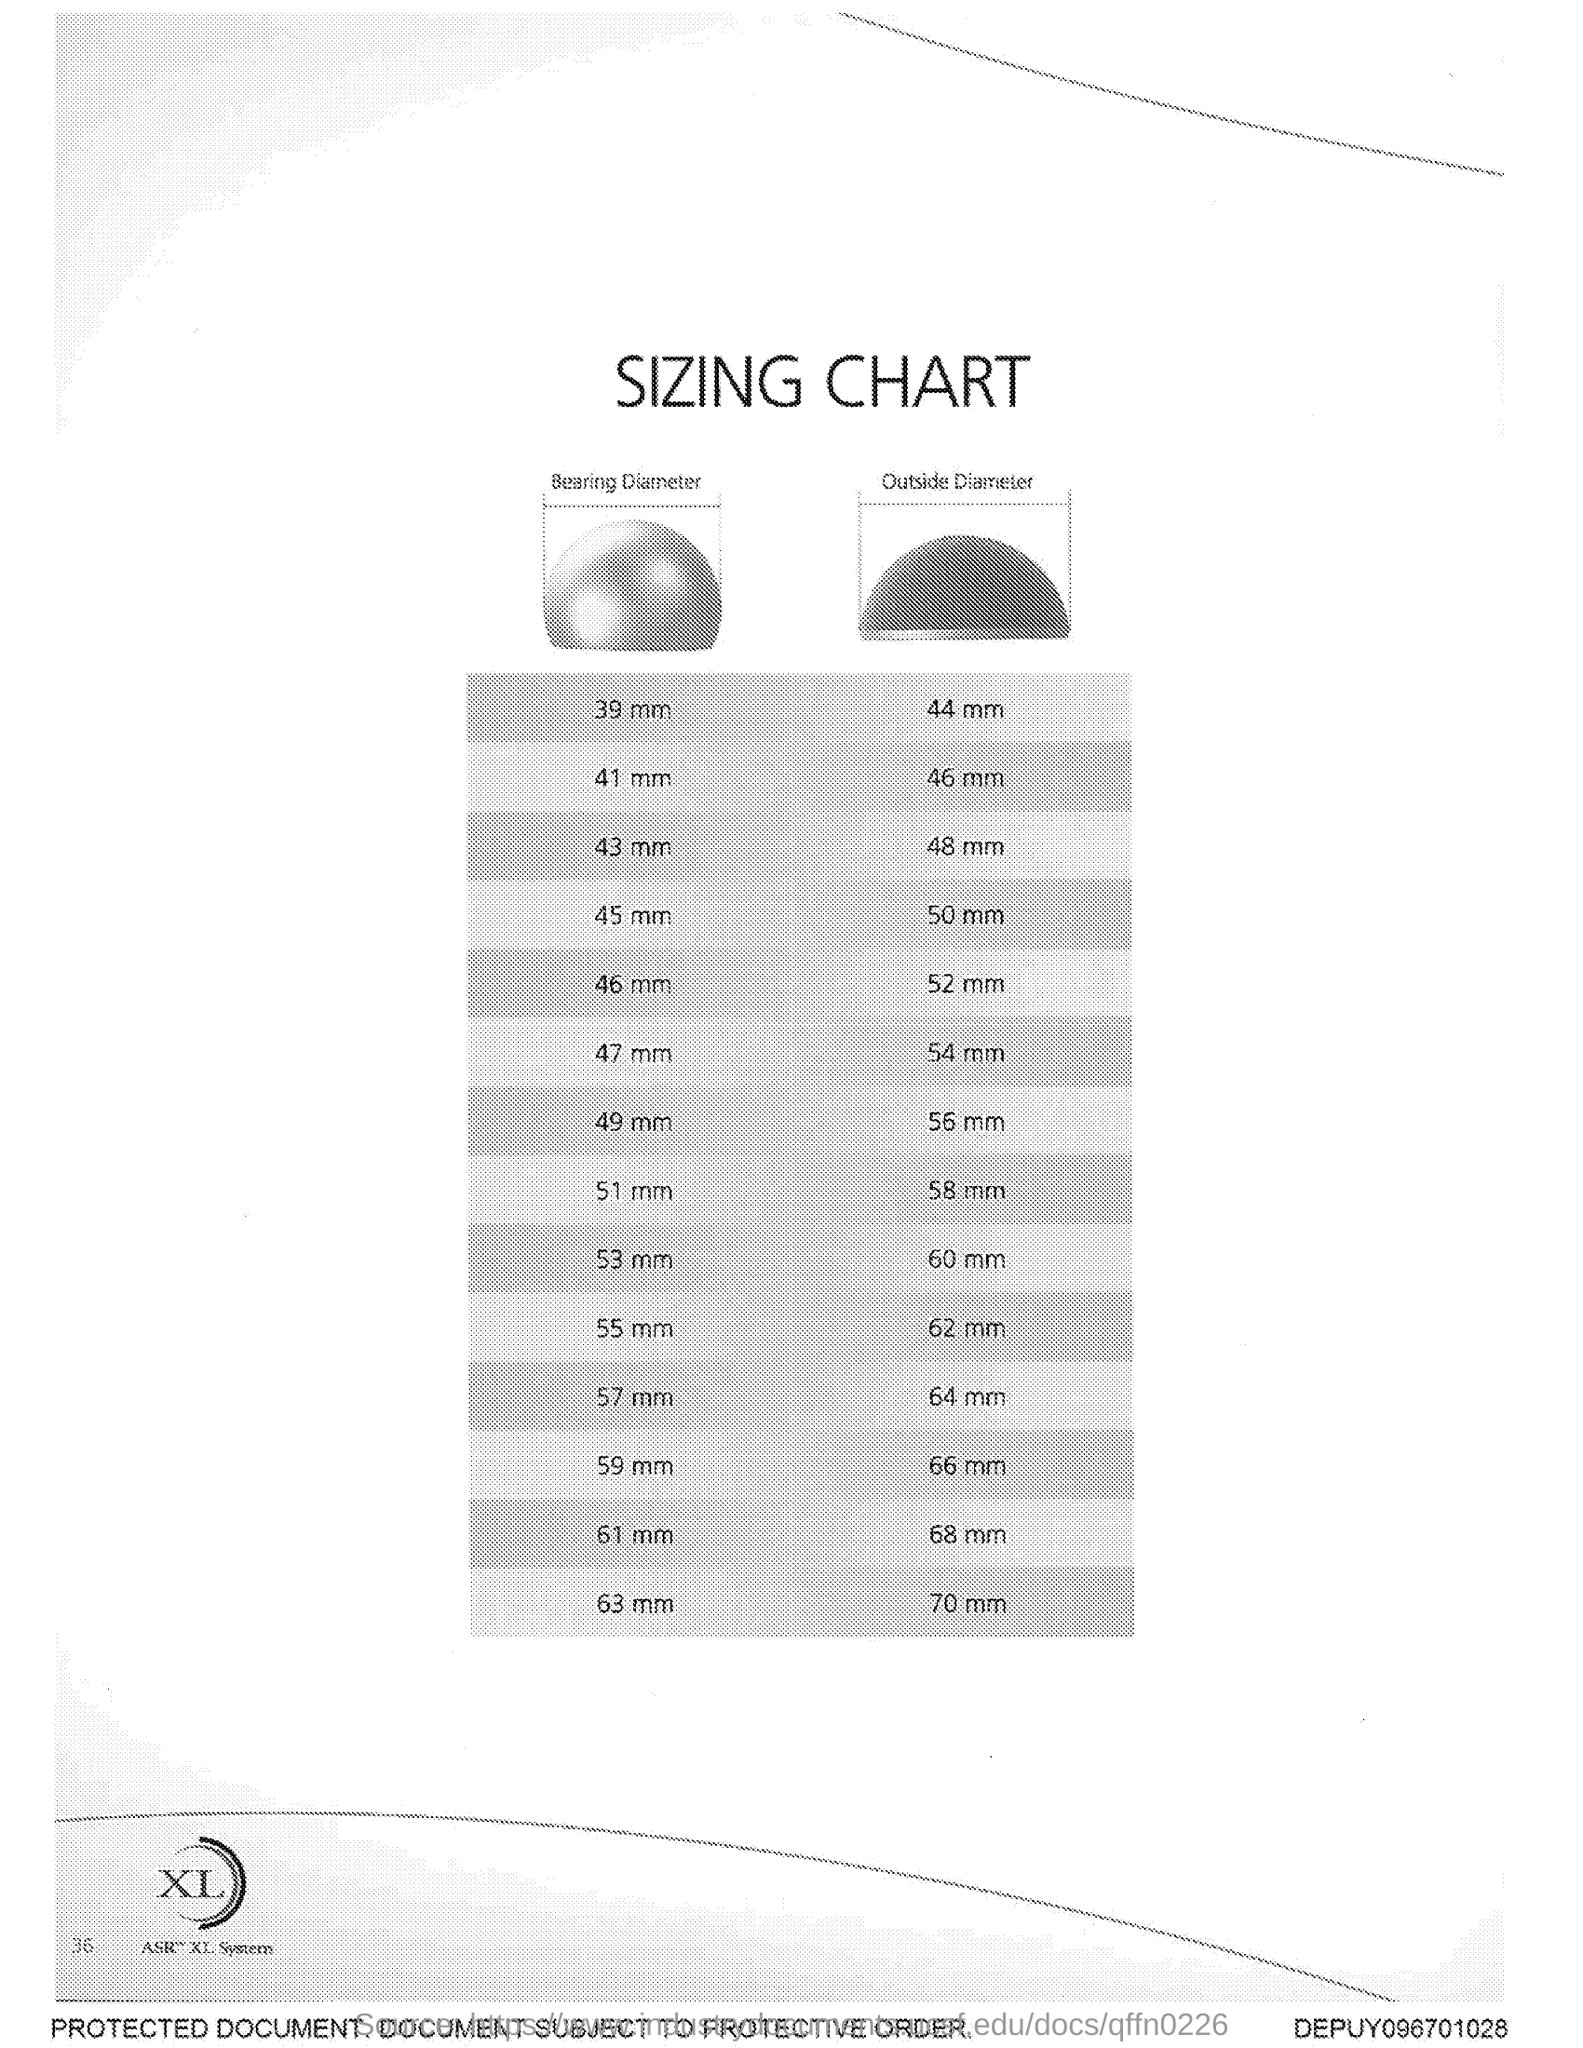What is the title of the document?
Offer a terse response. Sizing Chart. 